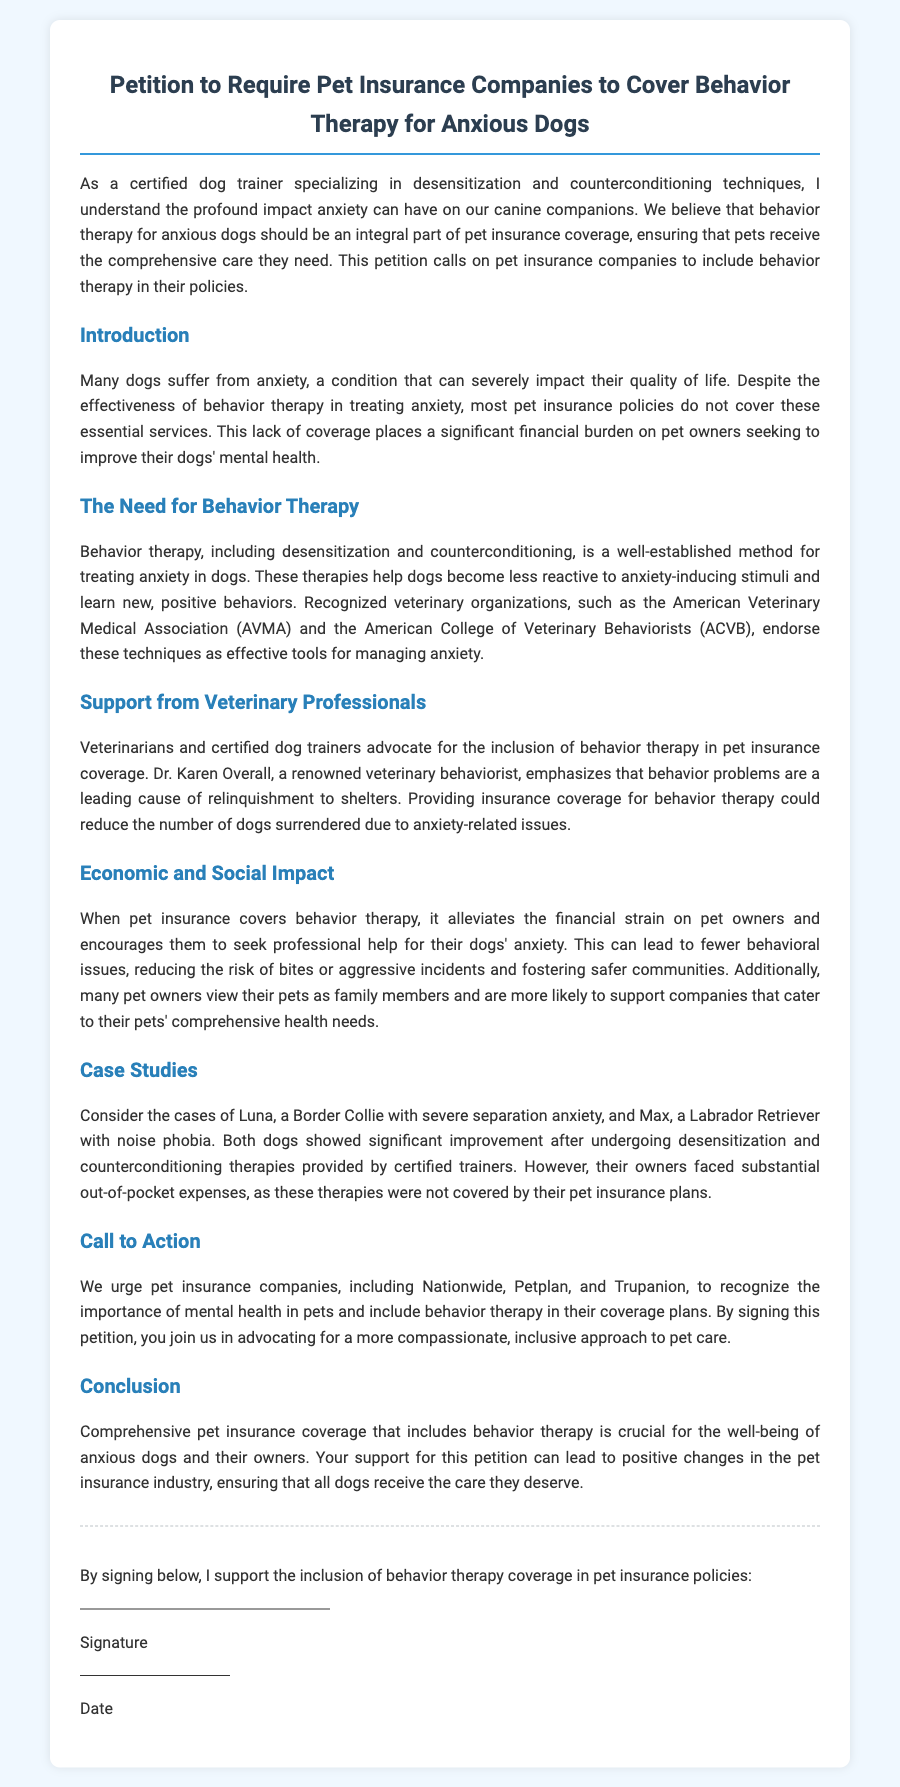What is the title of the petition? The title of the petition is stated prominently at the beginning of the document.
Answer: Petition to Require Pet Insurance Companies to Cover Behavior Therapy for Anxious Dogs Who is a renowned veterinary behaviorist mentioned in the petition? The document references a prominent figure advocating for behavior therapy coverage.
Answer: Dr. Karen Overall What is one technique used in behavior therapy for anxious dogs? The petition discusses specific methods for addressing canine anxiety.
Answer: Desensitization What type of impact includes economic benefits mentioned in the petition? The petition addresses a specific type of impact that includes financial considerations for pet owners.
Answer: Economic Which organizations endorse behavior therapy techniques? The document includes names of organizations that support the proposed therapies for dog anxiety.
Answer: American Veterinary Medical Association and the American College of Veterinary Behaviorists What is the main goal of the petition? The primary aim of the petition is highlighted in the call to action section.
Answer: To require pet insurance companies to cover behavior therapy What are the names of two companies mentioned in the petition? The document lists specific pet insurance companies as part of its call to action.
Answer: Nationwide, Petplan, and Trupanion How should supporters indicate their agreement with the petition? The document specifies how individuals can express their support for the petition.
Answer: By signing below 